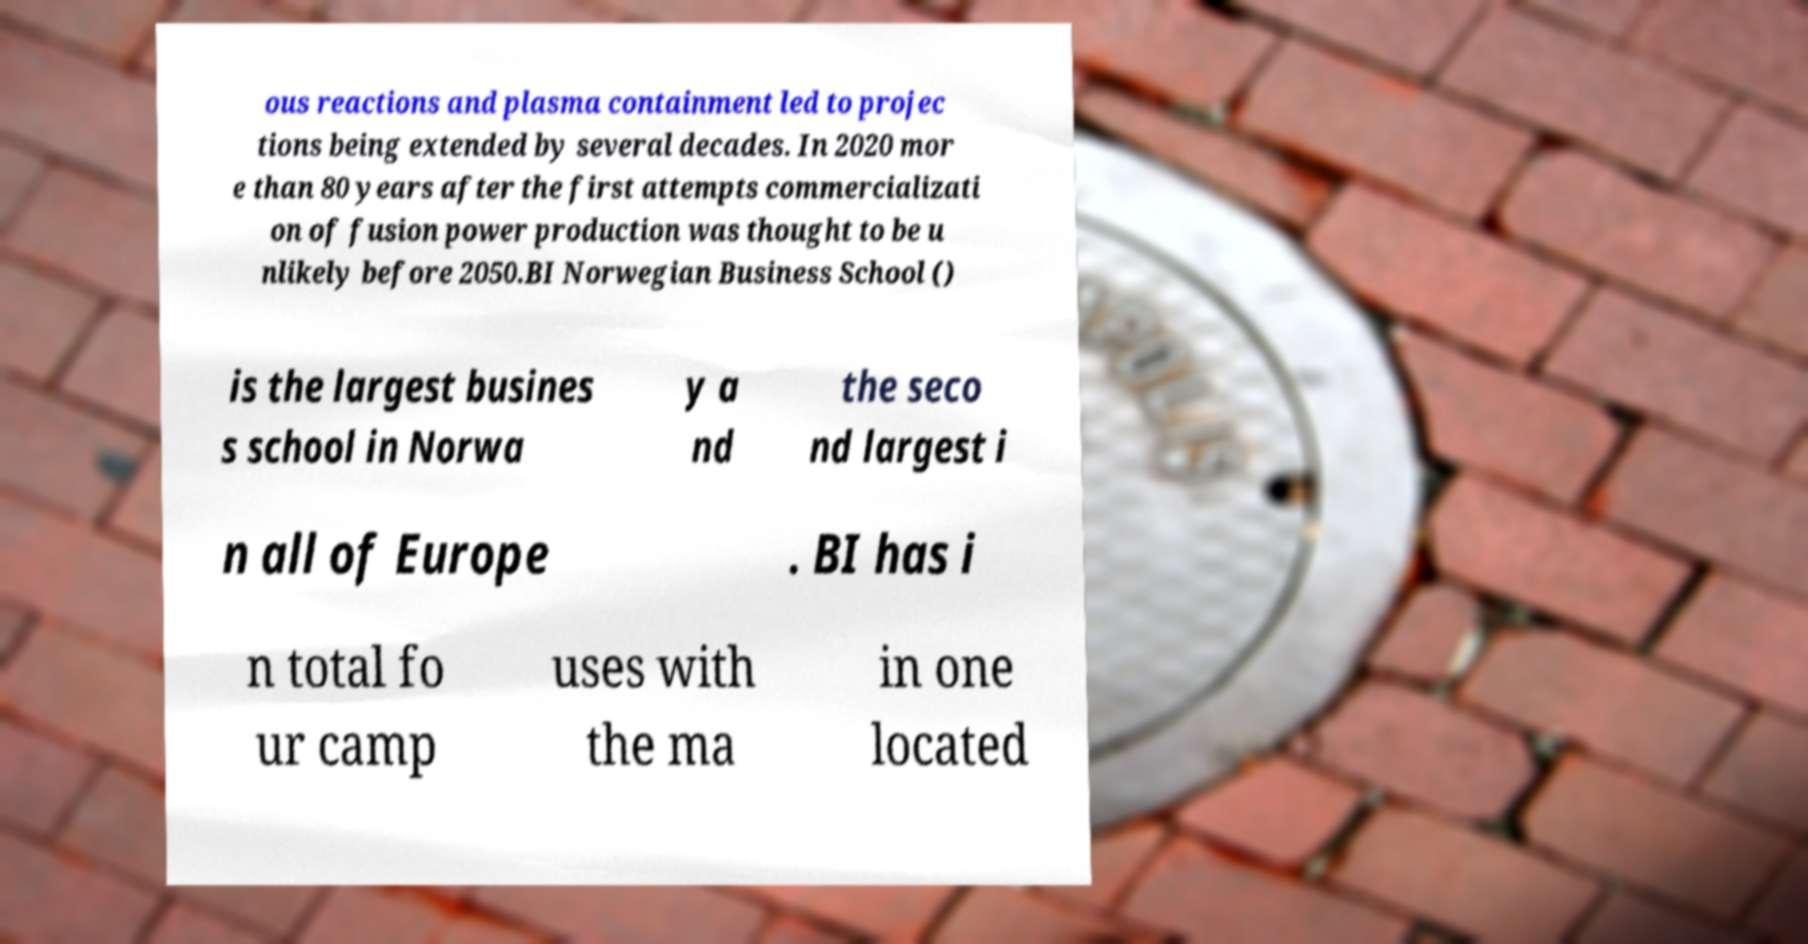Please identify and transcribe the text found in this image. ous reactions and plasma containment led to projec tions being extended by several decades. In 2020 mor e than 80 years after the first attempts commercializati on of fusion power production was thought to be u nlikely before 2050.BI Norwegian Business School () is the largest busines s school in Norwa y a nd the seco nd largest i n all of Europe . BI has i n total fo ur camp uses with the ma in one located 